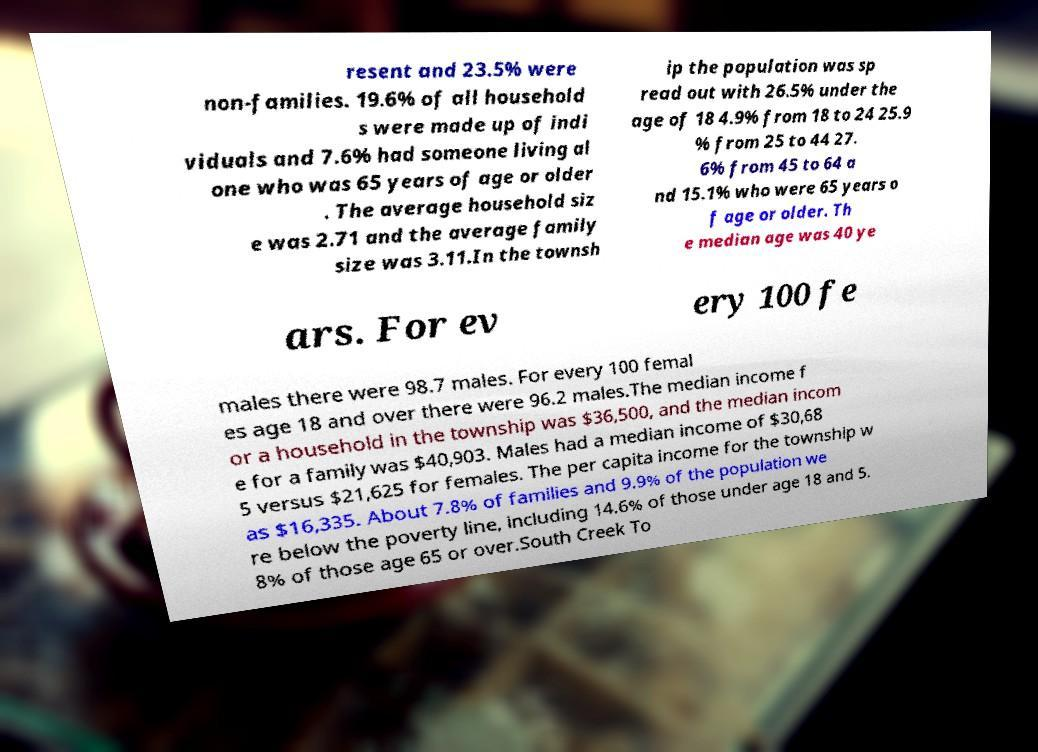There's text embedded in this image that I need extracted. Can you transcribe it verbatim? resent and 23.5% were non-families. 19.6% of all household s were made up of indi viduals and 7.6% had someone living al one who was 65 years of age or older . The average household siz e was 2.71 and the average family size was 3.11.In the townsh ip the population was sp read out with 26.5% under the age of 18 4.9% from 18 to 24 25.9 % from 25 to 44 27. 6% from 45 to 64 a nd 15.1% who were 65 years o f age or older. Th e median age was 40 ye ars. For ev ery 100 fe males there were 98.7 males. For every 100 femal es age 18 and over there were 96.2 males.The median income f or a household in the township was $36,500, and the median incom e for a family was $40,903. Males had a median income of $30,68 5 versus $21,625 for females. The per capita income for the township w as $16,335. About 7.8% of families and 9.9% of the population we re below the poverty line, including 14.6% of those under age 18 and 5. 8% of those age 65 or over.South Creek To 